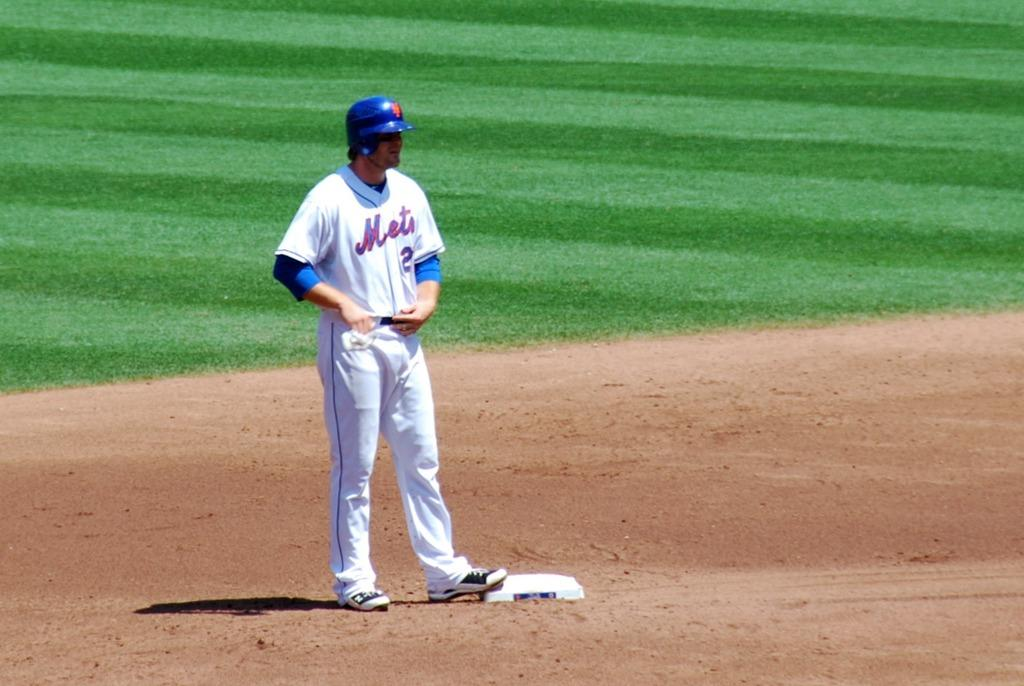<image>
Give a short and clear explanation of the subsequent image. Mets player #2 stands on base with a batting helmet on. 